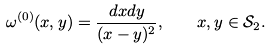<formula> <loc_0><loc_0><loc_500><loc_500>\omega ^ { ( 0 ) } ( x , y ) = \frac { d x d y } { ( x - y ) ^ { 2 } } , \quad x , y \in \mathcal { S } _ { 2 } .</formula> 